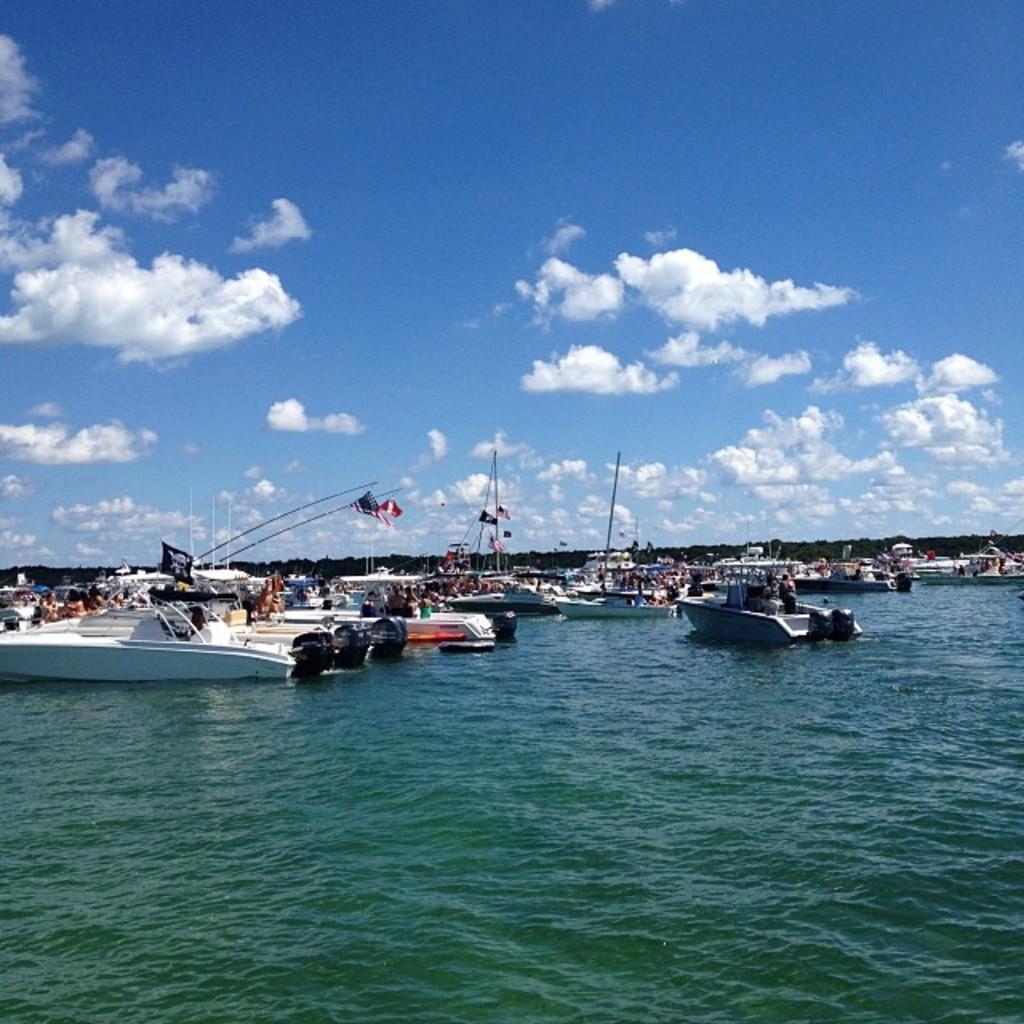How would you summarize this image in a sentence or two? In this image there is water and we can see boats on the water. In the background there are hills and sky. 